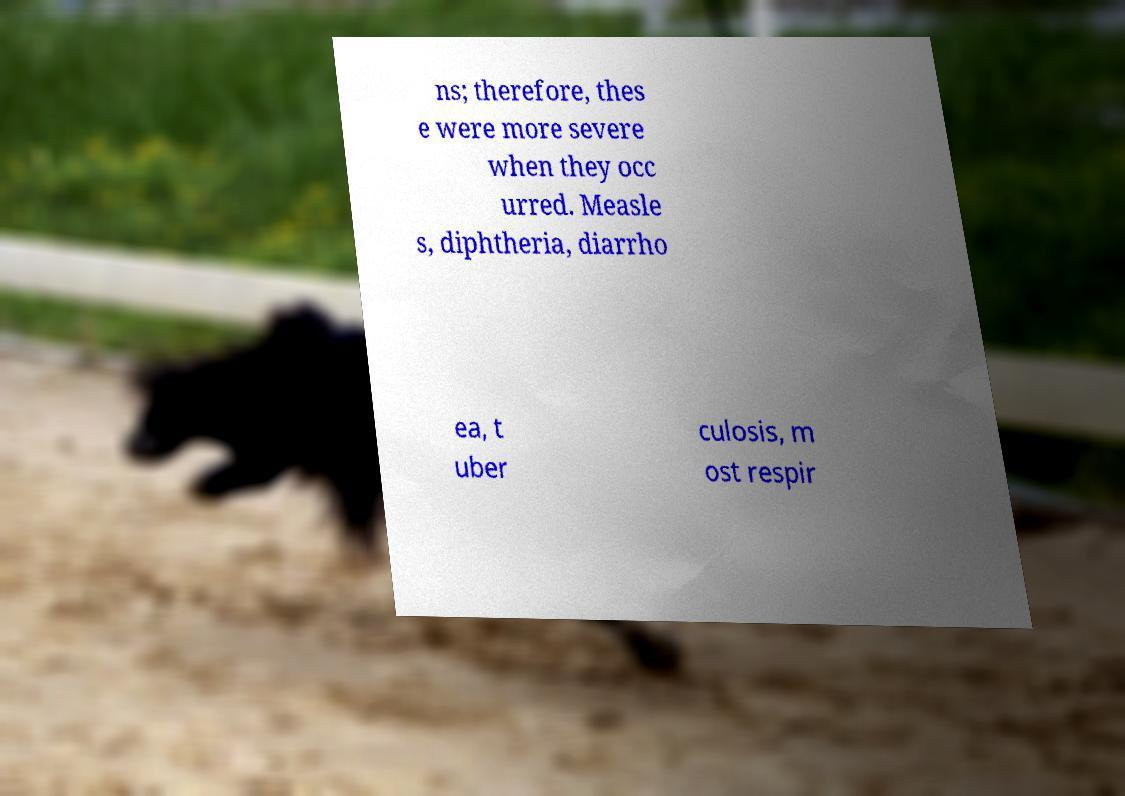I need the written content from this picture converted into text. Can you do that? ns; therefore, thes e were more severe when they occ urred. Measle s, diphtheria, diarrho ea, t uber culosis, m ost respir 